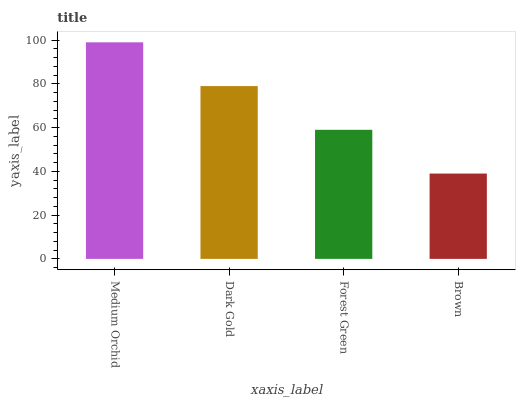Is Dark Gold the minimum?
Answer yes or no. No. Is Dark Gold the maximum?
Answer yes or no. No. Is Medium Orchid greater than Dark Gold?
Answer yes or no. Yes. Is Dark Gold less than Medium Orchid?
Answer yes or no. Yes. Is Dark Gold greater than Medium Orchid?
Answer yes or no. No. Is Medium Orchid less than Dark Gold?
Answer yes or no. No. Is Dark Gold the high median?
Answer yes or no. Yes. Is Forest Green the low median?
Answer yes or no. Yes. Is Forest Green the high median?
Answer yes or no. No. Is Brown the low median?
Answer yes or no. No. 